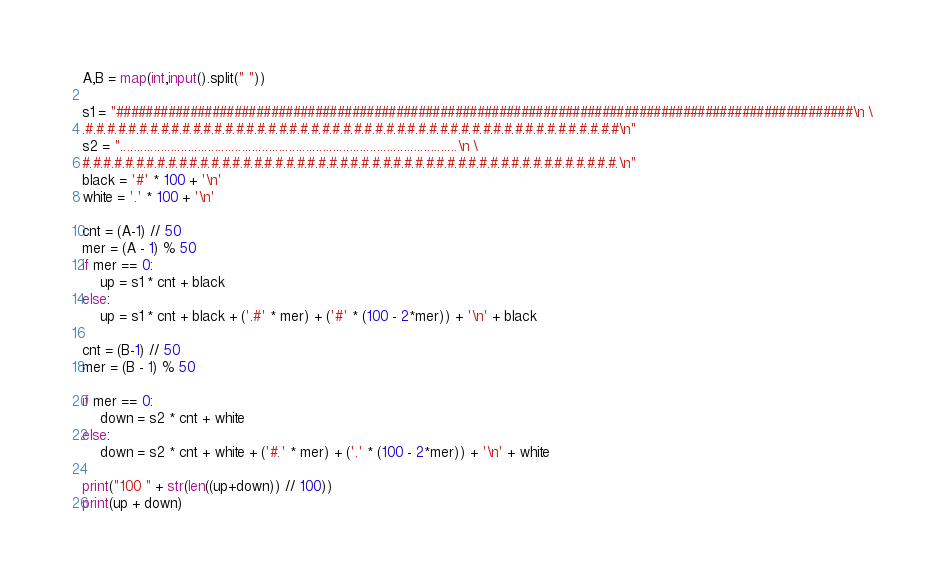<code> <loc_0><loc_0><loc_500><loc_500><_Python_>A,B = map(int,input().split(" "))

s1 = "####################################################################################################\n \
.#.#.#.#.#.#.#.#.#.#.#.#.#.#.#.#.#.#.#.#.#.#.#.#.#.#.#.#.#.#.#.#.#.#.#.#.#.#.#.#.#.#.#.#.#.#.#.#.#.#\n"
s2 = "....................................................................................................\n \
#.#.#.#.#.#.#.#.#.#.#.#.#.#.#.#.#.#.#.#.#.#.#.#.#.#.#.#.#.#.#.#.#.#.#.#.#.#.#.#.#.#.#.#.#.#.#.#.#.#.\n"
black = '#' * 100 + '\n'
white = '.' * 100 + '\n'

cnt = (A-1) // 50
mer = (A - 1) % 50
if mer == 0:
	up = s1 * cnt + black
else:
	up = s1 * cnt + black + ('.#' * mer) + ('#' * (100 - 2*mer)) + '\n' + black

cnt = (B-1) // 50
mer = (B - 1) % 50

if mer == 0:
	down = s2 * cnt + white
else:
	down = s2 * cnt + white + ('#.' * mer) + ('.' * (100 - 2*mer)) + '\n' + white

print("100 " + str(len((up+down)) // 100))
print(up + down)

</code> 